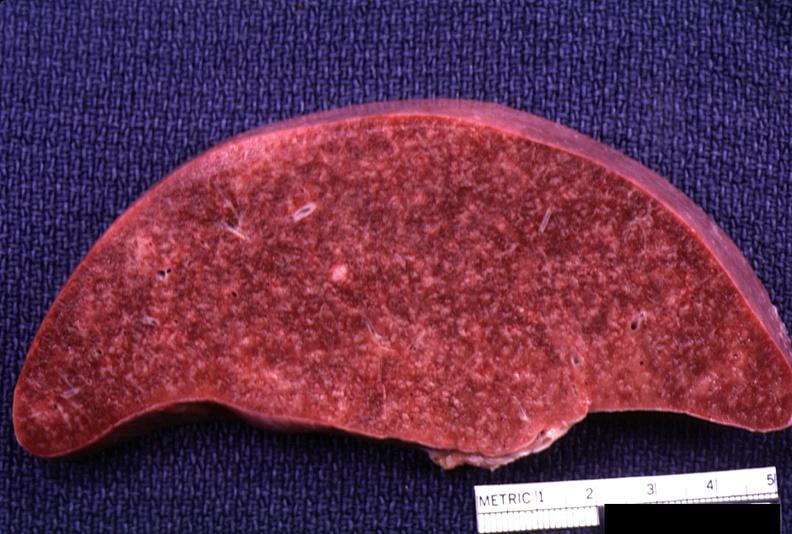what does this image show?
Answer the question using a single word or phrase. Spleen 